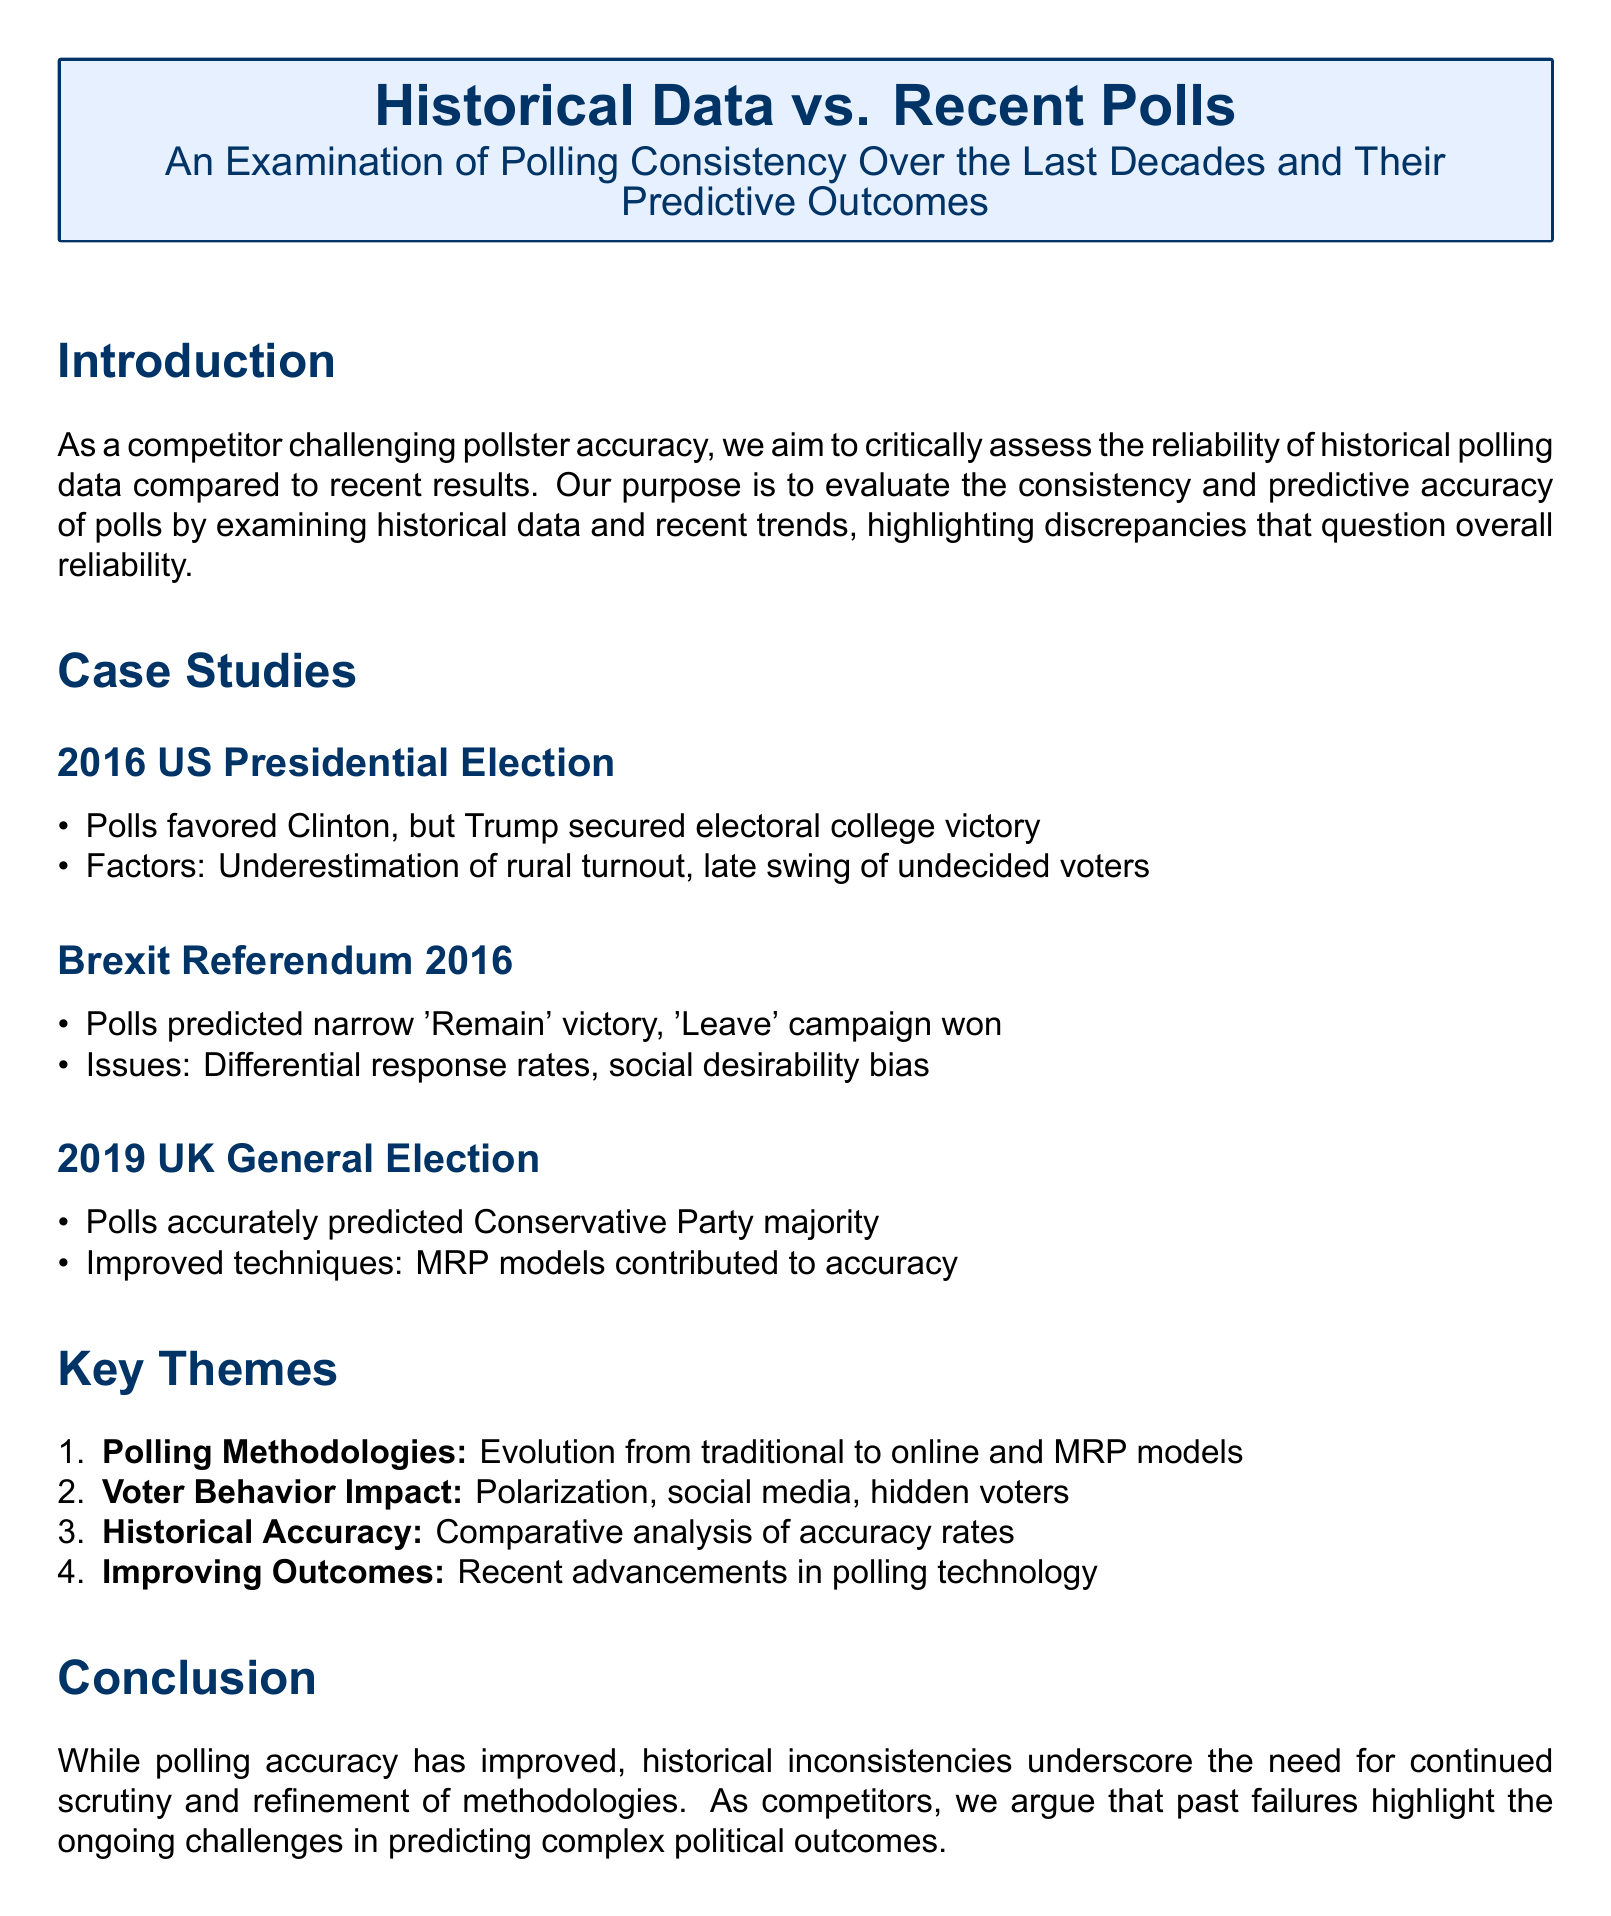What major event did the 2016 polls inaccurately predict? The document states that polls favored Clinton, but Trump secured the electoral college victory in the 2016 US Presidential Election.
Answer: Trump What campaign won in the Brexit Referendum 2016? It indicates that the 'Leave' campaign won in the Brexit Referendum despite polls predicting a 'Remain' victory.
Answer: Leave What polling technique contributed to the accuracy in the 2019 UK General Election? The document notes that improved MRP models contributed to the accuracy of polls in the 2019 UK General Election.
Answer: MRP models What is one key theme discussed in the document regarding polling methodologies? The document mentions the evolution from traditional to online techniques as one of the key themes in polling methodologies.
Answer: Evolution How did voter behavior impact polling predictions according to the document? It states that factors like polarization, social media, and hidden voters influenced polling predictions.
Answer: Polarization What challenge do past polling failures highlight? The document concludes that past polling failures underscore ongoing challenges in predicting complex political outcomes.
Answer: Challenges In which event did the polls accurately predict the Conservative Party majority? The document specifically states that polls accurately predicted the Conservative Party majority in the 2019 UK General Election.
Answer: 2019 UK General Election What is the main purpose of this case study? The main purpose outlined is to critically assess the reliability of historical polling data compared to recent results.
Answer: Assess reliability 